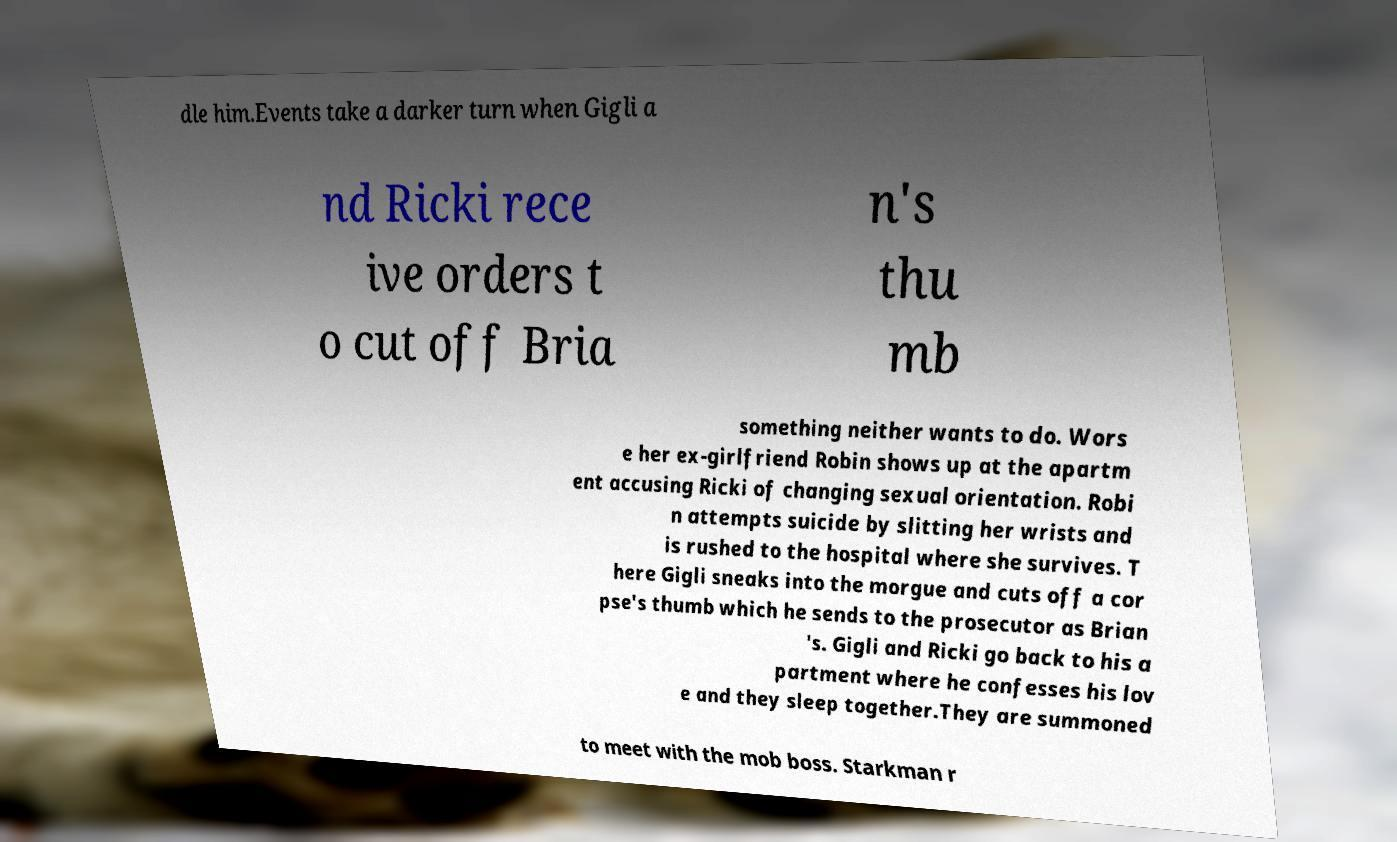What messages or text are displayed in this image? I need them in a readable, typed format. dle him.Events take a darker turn when Gigli a nd Ricki rece ive orders t o cut off Bria n's thu mb something neither wants to do. Wors e her ex-girlfriend Robin shows up at the apartm ent accusing Ricki of changing sexual orientation. Robi n attempts suicide by slitting her wrists and is rushed to the hospital where she survives. T here Gigli sneaks into the morgue and cuts off a cor pse's thumb which he sends to the prosecutor as Brian 's. Gigli and Ricki go back to his a partment where he confesses his lov e and they sleep together.They are summoned to meet with the mob boss. Starkman r 